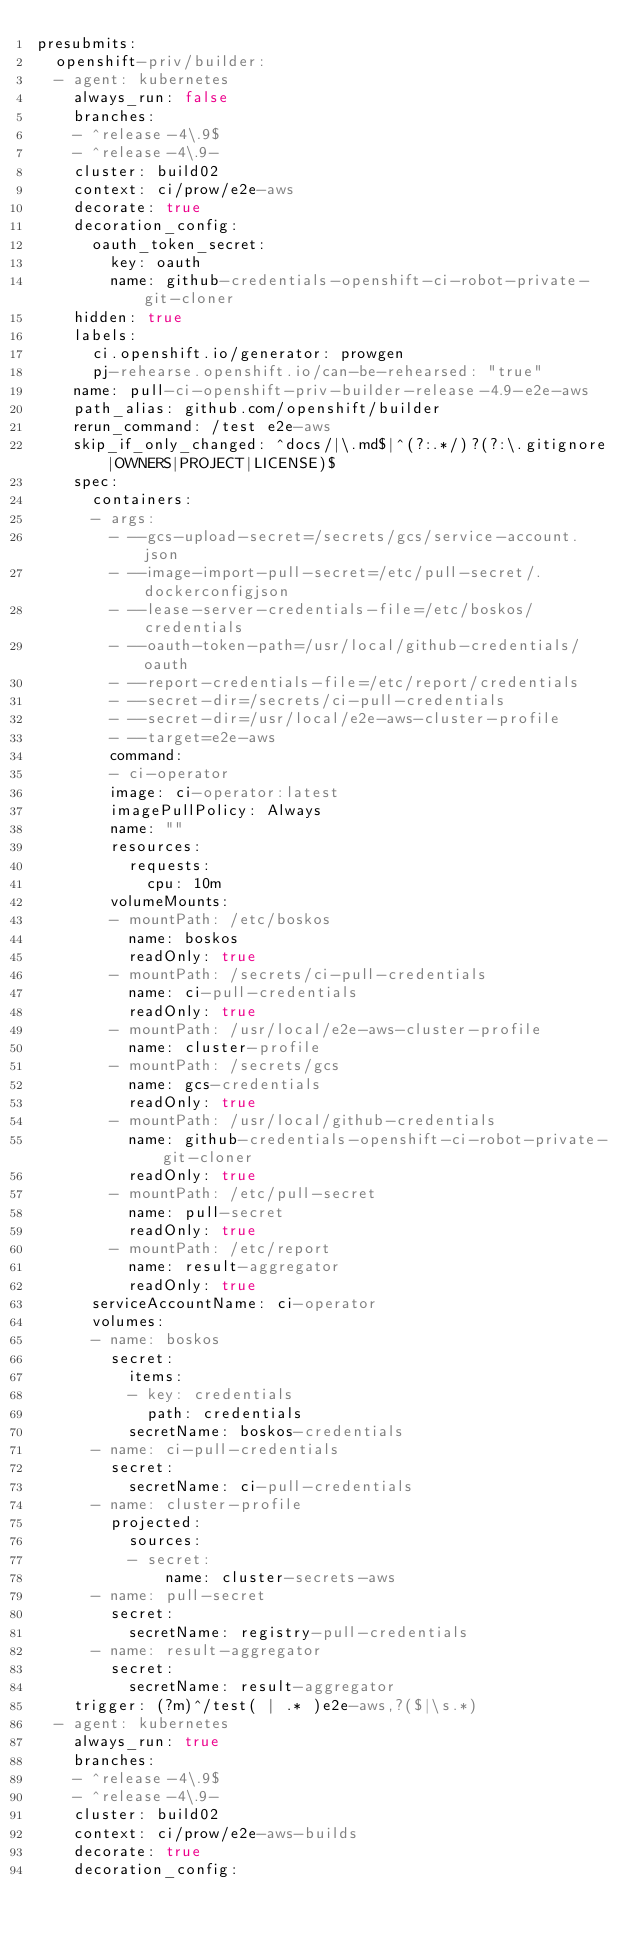<code> <loc_0><loc_0><loc_500><loc_500><_YAML_>presubmits:
  openshift-priv/builder:
  - agent: kubernetes
    always_run: false
    branches:
    - ^release-4\.9$
    - ^release-4\.9-
    cluster: build02
    context: ci/prow/e2e-aws
    decorate: true
    decoration_config:
      oauth_token_secret:
        key: oauth
        name: github-credentials-openshift-ci-robot-private-git-cloner
    hidden: true
    labels:
      ci.openshift.io/generator: prowgen
      pj-rehearse.openshift.io/can-be-rehearsed: "true"
    name: pull-ci-openshift-priv-builder-release-4.9-e2e-aws
    path_alias: github.com/openshift/builder
    rerun_command: /test e2e-aws
    skip_if_only_changed: ^docs/|\.md$|^(?:.*/)?(?:\.gitignore|OWNERS|PROJECT|LICENSE)$
    spec:
      containers:
      - args:
        - --gcs-upload-secret=/secrets/gcs/service-account.json
        - --image-import-pull-secret=/etc/pull-secret/.dockerconfigjson
        - --lease-server-credentials-file=/etc/boskos/credentials
        - --oauth-token-path=/usr/local/github-credentials/oauth
        - --report-credentials-file=/etc/report/credentials
        - --secret-dir=/secrets/ci-pull-credentials
        - --secret-dir=/usr/local/e2e-aws-cluster-profile
        - --target=e2e-aws
        command:
        - ci-operator
        image: ci-operator:latest
        imagePullPolicy: Always
        name: ""
        resources:
          requests:
            cpu: 10m
        volumeMounts:
        - mountPath: /etc/boskos
          name: boskos
          readOnly: true
        - mountPath: /secrets/ci-pull-credentials
          name: ci-pull-credentials
          readOnly: true
        - mountPath: /usr/local/e2e-aws-cluster-profile
          name: cluster-profile
        - mountPath: /secrets/gcs
          name: gcs-credentials
          readOnly: true
        - mountPath: /usr/local/github-credentials
          name: github-credentials-openshift-ci-robot-private-git-cloner
          readOnly: true
        - mountPath: /etc/pull-secret
          name: pull-secret
          readOnly: true
        - mountPath: /etc/report
          name: result-aggregator
          readOnly: true
      serviceAccountName: ci-operator
      volumes:
      - name: boskos
        secret:
          items:
          - key: credentials
            path: credentials
          secretName: boskos-credentials
      - name: ci-pull-credentials
        secret:
          secretName: ci-pull-credentials
      - name: cluster-profile
        projected:
          sources:
          - secret:
              name: cluster-secrets-aws
      - name: pull-secret
        secret:
          secretName: registry-pull-credentials
      - name: result-aggregator
        secret:
          secretName: result-aggregator
    trigger: (?m)^/test( | .* )e2e-aws,?($|\s.*)
  - agent: kubernetes
    always_run: true
    branches:
    - ^release-4\.9$
    - ^release-4\.9-
    cluster: build02
    context: ci/prow/e2e-aws-builds
    decorate: true
    decoration_config:</code> 